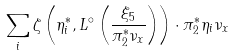Convert formula to latex. <formula><loc_0><loc_0><loc_500><loc_500>\sum _ { i } \zeta \left ( \eta _ { i } ^ { * } , L ^ { \circ } \left ( \frac { \xi _ { 5 } } { \pi _ { 2 } ^ { * } \nu _ { x } } \right ) \right ) \cdot \pi _ { 2 } ^ { * } \eta _ { i } \nu _ { x }</formula> 